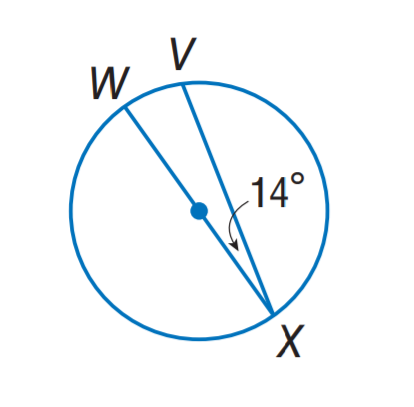Question: Find m \widehat V X.
Choices:
A. 28
B. 71
C. 152
D. 166
Answer with the letter. Answer: C 